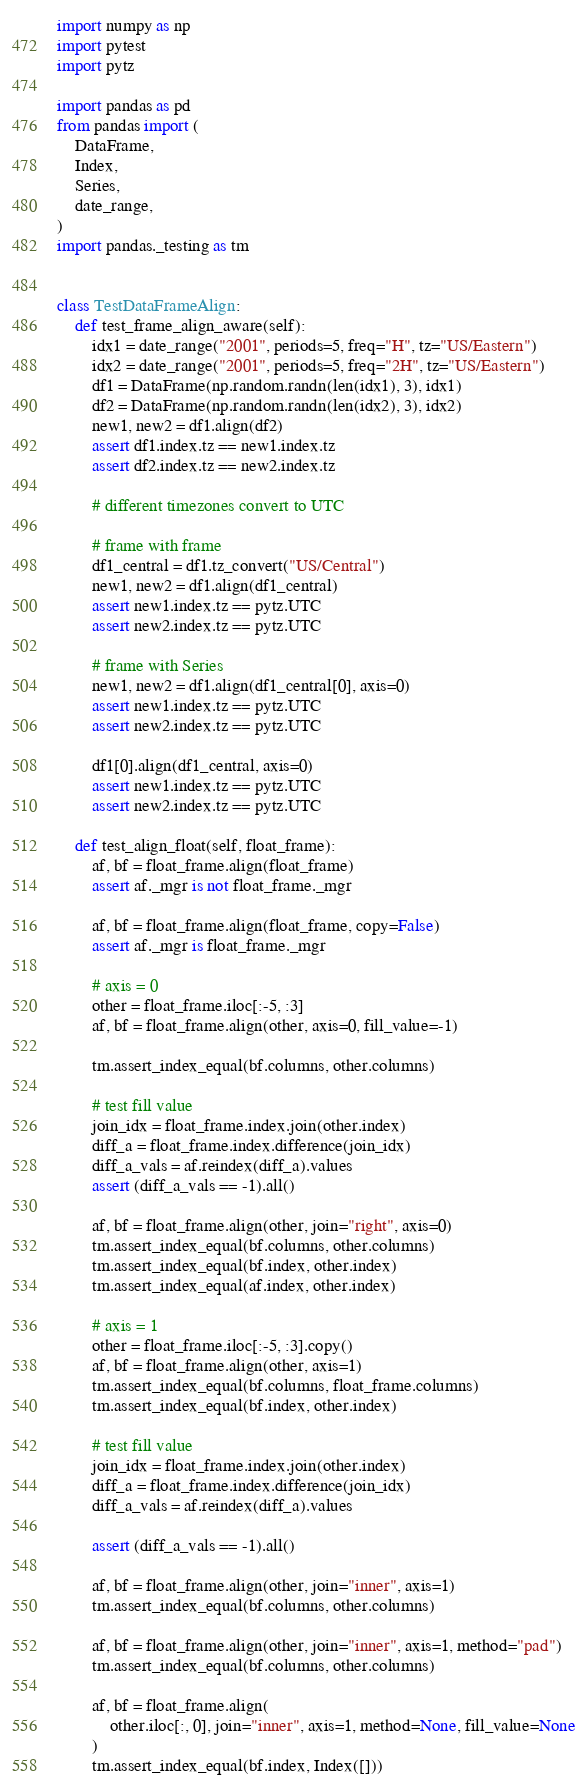<code> <loc_0><loc_0><loc_500><loc_500><_Python_>import numpy as np
import pytest
import pytz

import pandas as pd
from pandas import (
    DataFrame,
    Index,
    Series,
    date_range,
)
import pandas._testing as tm


class TestDataFrameAlign:
    def test_frame_align_aware(self):
        idx1 = date_range("2001", periods=5, freq="H", tz="US/Eastern")
        idx2 = date_range("2001", periods=5, freq="2H", tz="US/Eastern")
        df1 = DataFrame(np.random.randn(len(idx1), 3), idx1)
        df2 = DataFrame(np.random.randn(len(idx2), 3), idx2)
        new1, new2 = df1.align(df2)
        assert df1.index.tz == new1.index.tz
        assert df2.index.tz == new2.index.tz

        # different timezones convert to UTC

        # frame with frame
        df1_central = df1.tz_convert("US/Central")
        new1, new2 = df1.align(df1_central)
        assert new1.index.tz == pytz.UTC
        assert new2.index.tz == pytz.UTC

        # frame with Series
        new1, new2 = df1.align(df1_central[0], axis=0)
        assert new1.index.tz == pytz.UTC
        assert new2.index.tz == pytz.UTC

        df1[0].align(df1_central, axis=0)
        assert new1.index.tz == pytz.UTC
        assert new2.index.tz == pytz.UTC

    def test_align_float(self, float_frame):
        af, bf = float_frame.align(float_frame)
        assert af._mgr is not float_frame._mgr

        af, bf = float_frame.align(float_frame, copy=False)
        assert af._mgr is float_frame._mgr

        # axis = 0
        other = float_frame.iloc[:-5, :3]
        af, bf = float_frame.align(other, axis=0, fill_value=-1)

        tm.assert_index_equal(bf.columns, other.columns)

        # test fill value
        join_idx = float_frame.index.join(other.index)
        diff_a = float_frame.index.difference(join_idx)
        diff_a_vals = af.reindex(diff_a).values
        assert (diff_a_vals == -1).all()

        af, bf = float_frame.align(other, join="right", axis=0)
        tm.assert_index_equal(bf.columns, other.columns)
        tm.assert_index_equal(bf.index, other.index)
        tm.assert_index_equal(af.index, other.index)

        # axis = 1
        other = float_frame.iloc[:-5, :3].copy()
        af, bf = float_frame.align(other, axis=1)
        tm.assert_index_equal(bf.columns, float_frame.columns)
        tm.assert_index_equal(bf.index, other.index)

        # test fill value
        join_idx = float_frame.index.join(other.index)
        diff_a = float_frame.index.difference(join_idx)
        diff_a_vals = af.reindex(diff_a).values

        assert (diff_a_vals == -1).all()

        af, bf = float_frame.align(other, join="inner", axis=1)
        tm.assert_index_equal(bf.columns, other.columns)

        af, bf = float_frame.align(other, join="inner", axis=1, method="pad")
        tm.assert_index_equal(bf.columns, other.columns)

        af, bf = float_frame.align(
            other.iloc[:, 0], join="inner", axis=1, method=None, fill_value=None
        )
        tm.assert_index_equal(bf.index, Index([]))
</code> 